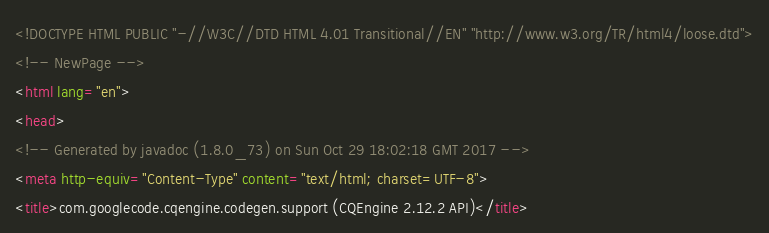<code> <loc_0><loc_0><loc_500><loc_500><_HTML_><!DOCTYPE HTML PUBLIC "-//W3C//DTD HTML 4.01 Transitional//EN" "http://www.w3.org/TR/html4/loose.dtd">
<!-- NewPage -->
<html lang="en">
<head>
<!-- Generated by javadoc (1.8.0_73) on Sun Oct 29 18:02:18 GMT 2017 -->
<meta http-equiv="Content-Type" content="text/html; charset=UTF-8">
<title>com.googlecode.cqengine.codegen.support (CQEngine 2.12.2 API)</title></code> 